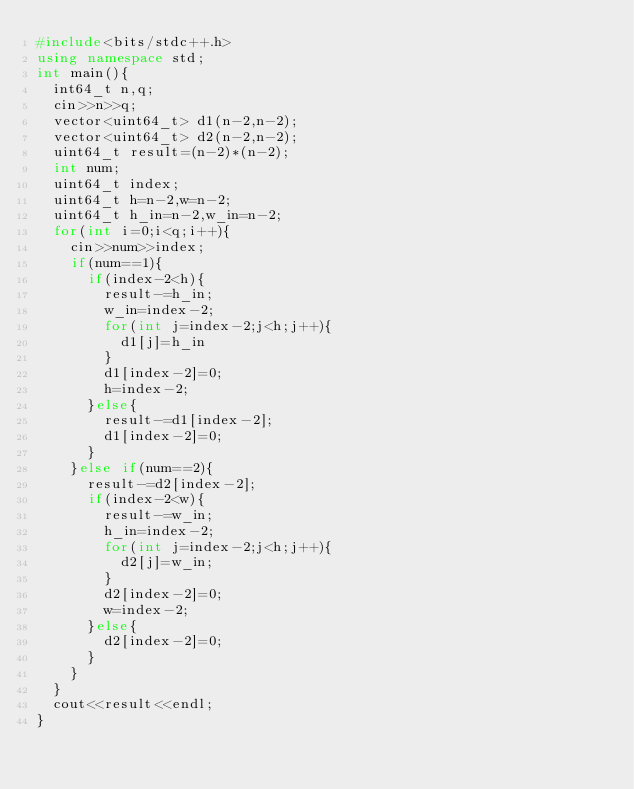Convert code to text. <code><loc_0><loc_0><loc_500><loc_500><_C++_>#include<bits/stdc++.h>
using namespace std;
int main(){
  int64_t n,q;
  cin>>n>>q;
  vector<uint64_t> d1(n-2,n-2);
  vector<uint64_t> d2(n-2,n-2);
  uint64_t result=(n-2)*(n-2);
  int num;
  uint64_t index;
  uint64_t h=n-2,w=n-2;
  uint64_t h_in=n-2,w_in=n-2;
  for(int i=0;i<q;i++){
    cin>>num>>index;
    if(num==1){
      if(index-2<h){
        result-=h_in;
        w_in=index-2;
        for(int j=index-2;j<h;j++){
          d1[j]=h_in
        }
        d1[index-2]=0;
        h=index-2;
      }else{
        result-=d1[index-2];
        d1[index-2]=0;
      }
    }else if(num==2){
      result-=d2[index-2];
      if(index-2<w){
        result-=w_in;
        h_in=index-2;
        for(int j=index-2;j<h;j++){
          d2[j]=w_in;
        }
        d2[index-2]=0;
        w=index-2;
      }else{
        d2[index-2]=0;
      }
    }
  }
  cout<<result<<endl;
}</code> 